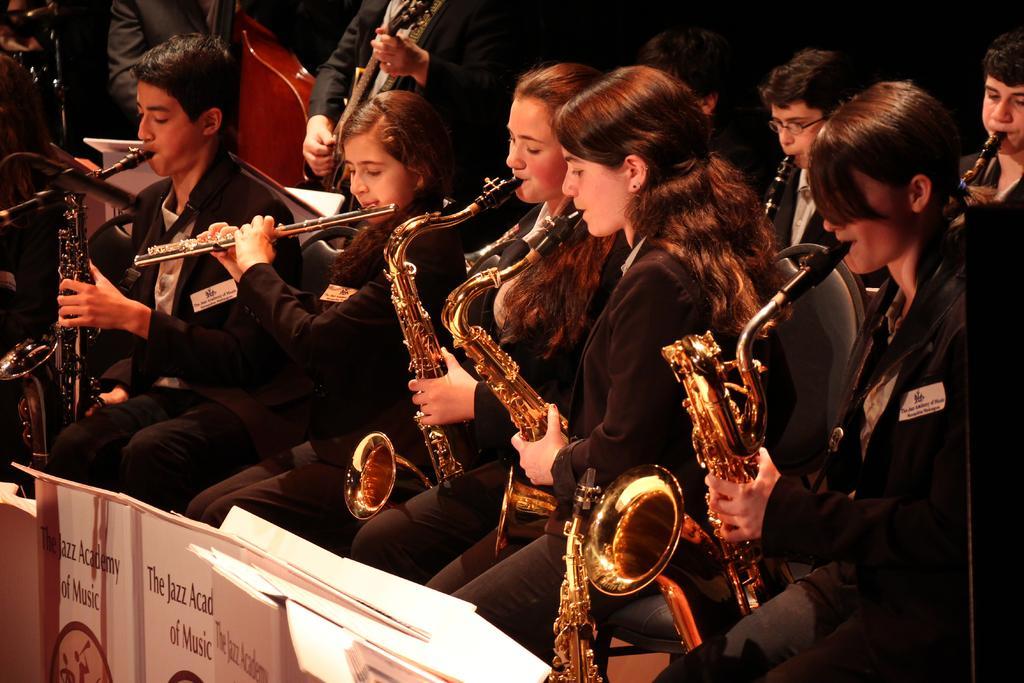Please provide a concise description of this image. In the foreground of this image, at the bottom, there are book holders and we can also see people sitting and playing musical instruments like saxophone, flute, guitar and also a violin at the top. 